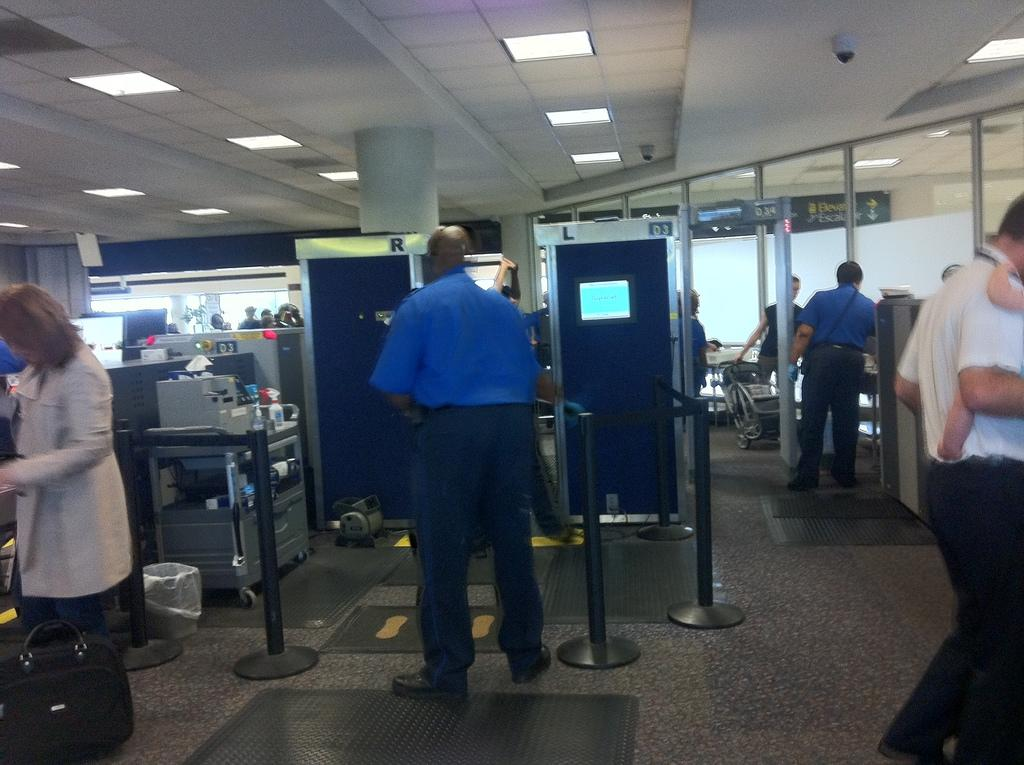What can be seen in the image involving people? There are people standing in the image. What type of machines are present in the image? There are machines in the image, including security check machines. Can you describe any other objects in the image? Yes, there are other objects in the image, but their specific details are not mentioned in the provided facts. What is located on the roof in the image? There are lights on the roof in the image. Can you tell me how many zippers are visible on the people in the image? There is no mention of zippers in the image, so it is not possible to determine their presence or quantity. What type of walk is being performed by the people in the image? The provided facts do not mention any specific type of walk being performed by the people in the image. 